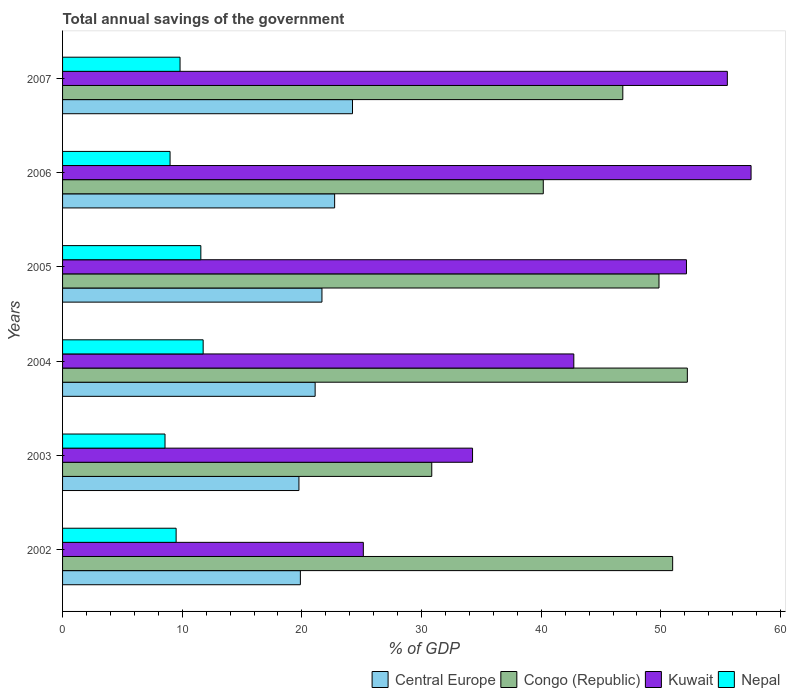How many different coloured bars are there?
Offer a terse response. 4. Are the number of bars per tick equal to the number of legend labels?
Your answer should be very brief. Yes. How many bars are there on the 4th tick from the top?
Keep it short and to the point. 4. How many bars are there on the 6th tick from the bottom?
Your response must be concise. 4. What is the total annual savings of the government in Kuwait in 2007?
Keep it short and to the point. 55.55. Across all years, what is the maximum total annual savings of the government in Nepal?
Your response must be concise. 11.75. Across all years, what is the minimum total annual savings of the government in Congo (Republic)?
Your response must be concise. 30.85. In which year was the total annual savings of the government in Nepal maximum?
Offer a very short reply. 2004. What is the total total annual savings of the government in Nepal in the graph?
Ensure brevity in your answer.  60.16. What is the difference between the total annual savings of the government in Nepal in 2003 and that in 2004?
Your response must be concise. -3.19. What is the difference between the total annual savings of the government in Congo (Republic) in 2004 and the total annual savings of the government in Kuwait in 2003?
Your response must be concise. 17.95. What is the average total annual savings of the government in Nepal per year?
Your answer should be very brief. 10.03. In the year 2005, what is the difference between the total annual savings of the government in Nepal and total annual savings of the government in Kuwait?
Your answer should be very brief. -40.58. In how many years, is the total annual savings of the government in Congo (Republic) greater than 18 %?
Ensure brevity in your answer.  6. What is the ratio of the total annual savings of the government in Central Europe in 2005 to that in 2007?
Your answer should be very brief. 0.89. Is the total annual savings of the government in Congo (Republic) in 2002 less than that in 2003?
Provide a succinct answer. No. What is the difference between the highest and the second highest total annual savings of the government in Nepal?
Your answer should be very brief. 0.19. What is the difference between the highest and the lowest total annual savings of the government in Kuwait?
Offer a very short reply. 32.4. Is it the case that in every year, the sum of the total annual savings of the government in Kuwait and total annual savings of the government in Congo (Republic) is greater than the sum of total annual savings of the government in Nepal and total annual savings of the government in Central Europe?
Offer a terse response. No. What does the 2nd bar from the top in 2004 represents?
Keep it short and to the point. Kuwait. What does the 4th bar from the bottom in 2006 represents?
Your response must be concise. Nepal. Is it the case that in every year, the sum of the total annual savings of the government in Congo (Republic) and total annual savings of the government in Kuwait is greater than the total annual savings of the government in Nepal?
Make the answer very short. Yes. Are all the bars in the graph horizontal?
Provide a succinct answer. Yes. What is the difference between two consecutive major ticks on the X-axis?
Keep it short and to the point. 10. Are the values on the major ticks of X-axis written in scientific E-notation?
Offer a very short reply. No. Where does the legend appear in the graph?
Keep it short and to the point. Bottom right. What is the title of the graph?
Provide a succinct answer. Total annual savings of the government. What is the label or title of the X-axis?
Your answer should be very brief. % of GDP. What is the label or title of the Y-axis?
Your response must be concise. Years. What is the % of GDP in Central Europe in 2002?
Your answer should be very brief. 19.87. What is the % of GDP of Congo (Republic) in 2002?
Offer a terse response. 50.98. What is the % of GDP of Kuwait in 2002?
Offer a terse response. 25.13. What is the % of GDP of Nepal in 2002?
Ensure brevity in your answer.  9.49. What is the % of GDP of Central Europe in 2003?
Your response must be concise. 19.75. What is the % of GDP of Congo (Republic) in 2003?
Your response must be concise. 30.85. What is the % of GDP of Kuwait in 2003?
Your answer should be compact. 34.26. What is the % of GDP of Nepal in 2003?
Your answer should be compact. 8.56. What is the % of GDP of Central Europe in 2004?
Make the answer very short. 21.11. What is the % of GDP of Congo (Republic) in 2004?
Provide a succinct answer. 52.21. What is the % of GDP in Kuwait in 2004?
Give a very brief answer. 42.72. What is the % of GDP in Nepal in 2004?
Your answer should be very brief. 11.75. What is the % of GDP of Central Europe in 2005?
Make the answer very short. 21.68. What is the % of GDP of Congo (Republic) in 2005?
Provide a short and direct response. 49.84. What is the % of GDP of Kuwait in 2005?
Your answer should be very brief. 52.14. What is the % of GDP in Nepal in 2005?
Keep it short and to the point. 11.56. What is the % of GDP of Central Europe in 2006?
Provide a succinct answer. 22.74. What is the % of GDP in Congo (Republic) in 2006?
Your answer should be compact. 40.17. What is the % of GDP of Kuwait in 2006?
Provide a succinct answer. 57.54. What is the % of GDP in Nepal in 2006?
Make the answer very short. 8.98. What is the % of GDP of Central Europe in 2007?
Provide a succinct answer. 24.23. What is the % of GDP of Congo (Republic) in 2007?
Offer a terse response. 46.82. What is the % of GDP in Kuwait in 2007?
Your response must be concise. 55.55. What is the % of GDP of Nepal in 2007?
Give a very brief answer. 9.82. Across all years, what is the maximum % of GDP of Central Europe?
Give a very brief answer. 24.23. Across all years, what is the maximum % of GDP of Congo (Republic)?
Your answer should be compact. 52.21. Across all years, what is the maximum % of GDP in Kuwait?
Give a very brief answer. 57.54. Across all years, what is the maximum % of GDP in Nepal?
Keep it short and to the point. 11.75. Across all years, what is the minimum % of GDP in Central Europe?
Provide a succinct answer. 19.75. Across all years, what is the minimum % of GDP in Congo (Republic)?
Provide a succinct answer. 30.85. Across all years, what is the minimum % of GDP in Kuwait?
Offer a very short reply. 25.13. Across all years, what is the minimum % of GDP of Nepal?
Your response must be concise. 8.56. What is the total % of GDP of Central Europe in the graph?
Keep it short and to the point. 129.38. What is the total % of GDP in Congo (Republic) in the graph?
Offer a very short reply. 270.88. What is the total % of GDP in Kuwait in the graph?
Your response must be concise. 267.35. What is the total % of GDP in Nepal in the graph?
Your answer should be compact. 60.16. What is the difference between the % of GDP of Central Europe in 2002 and that in 2003?
Offer a very short reply. 0.12. What is the difference between the % of GDP in Congo (Republic) in 2002 and that in 2003?
Your response must be concise. 20.13. What is the difference between the % of GDP in Kuwait in 2002 and that in 2003?
Your answer should be very brief. -9.13. What is the difference between the % of GDP of Nepal in 2002 and that in 2003?
Your response must be concise. 0.93. What is the difference between the % of GDP in Central Europe in 2002 and that in 2004?
Ensure brevity in your answer.  -1.23. What is the difference between the % of GDP of Congo (Republic) in 2002 and that in 2004?
Your answer should be compact. -1.23. What is the difference between the % of GDP of Kuwait in 2002 and that in 2004?
Offer a terse response. -17.59. What is the difference between the % of GDP of Nepal in 2002 and that in 2004?
Offer a terse response. -2.26. What is the difference between the % of GDP of Central Europe in 2002 and that in 2005?
Offer a very short reply. -1.8. What is the difference between the % of GDP in Congo (Republic) in 2002 and that in 2005?
Offer a very short reply. 1.14. What is the difference between the % of GDP of Kuwait in 2002 and that in 2005?
Keep it short and to the point. -27. What is the difference between the % of GDP of Nepal in 2002 and that in 2005?
Your answer should be very brief. -2.07. What is the difference between the % of GDP in Central Europe in 2002 and that in 2006?
Provide a succinct answer. -2.86. What is the difference between the % of GDP in Congo (Republic) in 2002 and that in 2006?
Give a very brief answer. 10.81. What is the difference between the % of GDP in Kuwait in 2002 and that in 2006?
Give a very brief answer. -32.4. What is the difference between the % of GDP in Nepal in 2002 and that in 2006?
Your answer should be compact. 0.51. What is the difference between the % of GDP of Central Europe in 2002 and that in 2007?
Keep it short and to the point. -4.36. What is the difference between the % of GDP in Congo (Republic) in 2002 and that in 2007?
Keep it short and to the point. 4.17. What is the difference between the % of GDP of Kuwait in 2002 and that in 2007?
Offer a very short reply. -30.42. What is the difference between the % of GDP of Nepal in 2002 and that in 2007?
Ensure brevity in your answer.  -0.33. What is the difference between the % of GDP of Central Europe in 2003 and that in 2004?
Give a very brief answer. -1.35. What is the difference between the % of GDP of Congo (Republic) in 2003 and that in 2004?
Offer a terse response. -21.36. What is the difference between the % of GDP of Kuwait in 2003 and that in 2004?
Ensure brevity in your answer.  -8.46. What is the difference between the % of GDP in Nepal in 2003 and that in 2004?
Provide a short and direct response. -3.19. What is the difference between the % of GDP in Central Europe in 2003 and that in 2005?
Offer a terse response. -1.92. What is the difference between the % of GDP of Congo (Republic) in 2003 and that in 2005?
Give a very brief answer. -18.99. What is the difference between the % of GDP of Kuwait in 2003 and that in 2005?
Your answer should be very brief. -17.88. What is the difference between the % of GDP in Nepal in 2003 and that in 2005?
Your answer should be very brief. -2.99. What is the difference between the % of GDP of Central Europe in 2003 and that in 2006?
Your answer should be very brief. -2.98. What is the difference between the % of GDP in Congo (Republic) in 2003 and that in 2006?
Offer a terse response. -9.32. What is the difference between the % of GDP of Kuwait in 2003 and that in 2006?
Your answer should be very brief. -23.28. What is the difference between the % of GDP in Nepal in 2003 and that in 2006?
Your response must be concise. -0.42. What is the difference between the % of GDP of Central Europe in 2003 and that in 2007?
Make the answer very short. -4.48. What is the difference between the % of GDP in Congo (Republic) in 2003 and that in 2007?
Offer a very short reply. -15.97. What is the difference between the % of GDP in Kuwait in 2003 and that in 2007?
Provide a succinct answer. -21.29. What is the difference between the % of GDP in Nepal in 2003 and that in 2007?
Your answer should be very brief. -1.26. What is the difference between the % of GDP of Central Europe in 2004 and that in 2005?
Ensure brevity in your answer.  -0.57. What is the difference between the % of GDP of Congo (Republic) in 2004 and that in 2005?
Keep it short and to the point. 2.37. What is the difference between the % of GDP of Kuwait in 2004 and that in 2005?
Provide a succinct answer. -9.41. What is the difference between the % of GDP in Nepal in 2004 and that in 2005?
Your answer should be very brief. 0.19. What is the difference between the % of GDP of Central Europe in 2004 and that in 2006?
Give a very brief answer. -1.63. What is the difference between the % of GDP in Congo (Republic) in 2004 and that in 2006?
Provide a succinct answer. 12.04. What is the difference between the % of GDP of Kuwait in 2004 and that in 2006?
Provide a succinct answer. -14.81. What is the difference between the % of GDP of Nepal in 2004 and that in 2006?
Your response must be concise. 2.77. What is the difference between the % of GDP of Central Europe in 2004 and that in 2007?
Provide a short and direct response. -3.12. What is the difference between the % of GDP of Congo (Republic) in 2004 and that in 2007?
Your response must be concise. 5.39. What is the difference between the % of GDP in Kuwait in 2004 and that in 2007?
Your response must be concise. -12.83. What is the difference between the % of GDP of Nepal in 2004 and that in 2007?
Make the answer very short. 1.93. What is the difference between the % of GDP of Central Europe in 2005 and that in 2006?
Make the answer very short. -1.06. What is the difference between the % of GDP in Congo (Republic) in 2005 and that in 2006?
Ensure brevity in your answer.  9.67. What is the difference between the % of GDP in Kuwait in 2005 and that in 2006?
Make the answer very short. -5.4. What is the difference between the % of GDP in Nepal in 2005 and that in 2006?
Give a very brief answer. 2.57. What is the difference between the % of GDP of Central Europe in 2005 and that in 2007?
Your answer should be very brief. -2.55. What is the difference between the % of GDP in Congo (Republic) in 2005 and that in 2007?
Give a very brief answer. 3.02. What is the difference between the % of GDP of Kuwait in 2005 and that in 2007?
Give a very brief answer. -3.42. What is the difference between the % of GDP of Nepal in 2005 and that in 2007?
Offer a very short reply. 1.74. What is the difference between the % of GDP in Central Europe in 2006 and that in 2007?
Keep it short and to the point. -1.49. What is the difference between the % of GDP in Congo (Republic) in 2006 and that in 2007?
Ensure brevity in your answer.  -6.65. What is the difference between the % of GDP of Kuwait in 2006 and that in 2007?
Provide a short and direct response. 1.98. What is the difference between the % of GDP of Nepal in 2006 and that in 2007?
Your answer should be compact. -0.83. What is the difference between the % of GDP of Central Europe in 2002 and the % of GDP of Congo (Republic) in 2003?
Offer a very short reply. -10.98. What is the difference between the % of GDP in Central Europe in 2002 and the % of GDP in Kuwait in 2003?
Offer a terse response. -14.39. What is the difference between the % of GDP in Central Europe in 2002 and the % of GDP in Nepal in 2003?
Offer a terse response. 11.31. What is the difference between the % of GDP of Congo (Republic) in 2002 and the % of GDP of Kuwait in 2003?
Provide a succinct answer. 16.72. What is the difference between the % of GDP in Congo (Republic) in 2002 and the % of GDP in Nepal in 2003?
Keep it short and to the point. 42.42. What is the difference between the % of GDP in Kuwait in 2002 and the % of GDP in Nepal in 2003?
Offer a terse response. 16.57. What is the difference between the % of GDP in Central Europe in 2002 and the % of GDP in Congo (Republic) in 2004?
Make the answer very short. -32.34. What is the difference between the % of GDP of Central Europe in 2002 and the % of GDP of Kuwait in 2004?
Your answer should be very brief. -22.85. What is the difference between the % of GDP in Central Europe in 2002 and the % of GDP in Nepal in 2004?
Provide a succinct answer. 8.12. What is the difference between the % of GDP of Congo (Republic) in 2002 and the % of GDP of Kuwait in 2004?
Your answer should be very brief. 8.26. What is the difference between the % of GDP of Congo (Republic) in 2002 and the % of GDP of Nepal in 2004?
Offer a terse response. 39.24. What is the difference between the % of GDP of Kuwait in 2002 and the % of GDP of Nepal in 2004?
Ensure brevity in your answer.  13.38. What is the difference between the % of GDP in Central Europe in 2002 and the % of GDP in Congo (Republic) in 2005?
Ensure brevity in your answer.  -29.97. What is the difference between the % of GDP in Central Europe in 2002 and the % of GDP in Kuwait in 2005?
Your response must be concise. -32.26. What is the difference between the % of GDP in Central Europe in 2002 and the % of GDP in Nepal in 2005?
Provide a short and direct response. 8.32. What is the difference between the % of GDP in Congo (Republic) in 2002 and the % of GDP in Kuwait in 2005?
Your answer should be very brief. -1.15. What is the difference between the % of GDP of Congo (Republic) in 2002 and the % of GDP of Nepal in 2005?
Ensure brevity in your answer.  39.43. What is the difference between the % of GDP in Kuwait in 2002 and the % of GDP in Nepal in 2005?
Make the answer very short. 13.58. What is the difference between the % of GDP of Central Europe in 2002 and the % of GDP of Congo (Republic) in 2006?
Give a very brief answer. -20.3. What is the difference between the % of GDP of Central Europe in 2002 and the % of GDP of Kuwait in 2006?
Keep it short and to the point. -37.66. What is the difference between the % of GDP in Central Europe in 2002 and the % of GDP in Nepal in 2006?
Your answer should be very brief. 10.89. What is the difference between the % of GDP in Congo (Republic) in 2002 and the % of GDP in Kuwait in 2006?
Provide a short and direct response. -6.55. What is the difference between the % of GDP of Congo (Republic) in 2002 and the % of GDP of Nepal in 2006?
Offer a terse response. 42. What is the difference between the % of GDP in Kuwait in 2002 and the % of GDP in Nepal in 2006?
Make the answer very short. 16.15. What is the difference between the % of GDP of Central Europe in 2002 and the % of GDP of Congo (Republic) in 2007?
Provide a succinct answer. -26.95. What is the difference between the % of GDP in Central Europe in 2002 and the % of GDP in Kuwait in 2007?
Your response must be concise. -35.68. What is the difference between the % of GDP in Central Europe in 2002 and the % of GDP in Nepal in 2007?
Give a very brief answer. 10.06. What is the difference between the % of GDP of Congo (Republic) in 2002 and the % of GDP of Kuwait in 2007?
Offer a very short reply. -4.57. What is the difference between the % of GDP in Congo (Republic) in 2002 and the % of GDP in Nepal in 2007?
Keep it short and to the point. 41.17. What is the difference between the % of GDP in Kuwait in 2002 and the % of GDP in Nepal in 2007?
Your answer should be compact. 15.32. What is the difference between the % of GDP of Central Europe in 2003 and the % of GDP of Congo (Republic) in 2004?
Give a very brief answer. -32.46. What is the difference between the % of GDP of Central Europe in 2003 and the % of GDP of Kuwait in 2004?
Give a very brief answer. -22.97. What is the difference between the % of GDP in Central Europe in 2003 and the % of GDP in Nepal in 2004?
Keep it short and to the point. 8. What is the difference between the % of GDP of Congo (Republic) in 2003 and the % of GDP of Kuwait in 2004?
Keep it short and to the point. -11.87. What is the difference between the % of GDP in Congo (Republic) in 2003 and the % of GDP in Nepal in 2004?
Your answer should be compact. 19.1. What is the difference between the % of GDP of Kuwait in 2003 and the % of GDP of Nepal in 2004?
Ensure brevity in your answer.  22.51. What is the difference between the % of GDP in Central Europe in 2003 and the % of GDP in Congo (Republic) in 2005?
Provide a succinct answer. -30.09. What is the difference between the % of GDP in Central Europe in 2003 and the % of GDP in Kuwait in 2005?
Your answer should be very brief. -32.39. What is the difference between the % of GDP in Central Europe in 2003 and the % of GDP in Nepal in 2005?
Offer a terse response. 8.2. What is the difference between the % of GDP in Congo (Republic) in 2003 and the % of GDP in Kuwait in 2005?
Offer a terse response. -21.29. What is the difference between the % of GDP in Congo (Republic) in 2003 and the % of GDP in Nepal in 2005?
Ensure brevity in your answer.  19.3. What is the difference between the % of GDP of Kuwait in 2003 and the % of GDP of Nepal in 2005?
Your answer should be compact. 22.71. What is the difference between the % of GDP of Central Europe in 2003 and the % of GDP of Congo (Republic) in 2006?
Offer a terse response. -20.42. What is the difference between the % of GDP in Central Europe in 2003 and the % of GDP in Kuwait in 2006?
Ensure brevity in your answer.  -37.78. What is the difference between the % of GDP in Central Europe in 2003 and the % of GDP in Nepal in 2006?
Your answer should be very brief. 10.77. What is the difference between the % of GDP in Congo (Republic) in 2003 and the % of GDP in Kuwait in 2006?
Your answer should be very brief. -26.68. What is the difference between the % of GDP of Congo (Republic) in 2003 and the % of GDP of Nepal in 2006?
Your answer should be very brief. 21.87. What is the difference between the % of GDP of Kuwait in 2003 and the % of GDP of Nepal in 2006?
Keep it short and to the point. 25.28. What is the difference between the % of GDP in Central Europe in 2003 and the % of GDP in Congo (Republic) in 2007?
Offer a terse response. -27.07. What is the difference between the % of GDP of Central Europe in 2003 and the % of GDP of Kuwait in 2007?
Your answer should be compact. -35.8. What is the difference between the % of GDP of Central Europe in 2003 and the % of GDP of Nepal in 2007?
Make the answer very short. 9.94. What is the difference between the % of GDP of Congo (Republic) in 2003 and the % of GDP of Kuwait in 2007?
Offer a terse response. -24.7. What is the difference between the % of GDP of Congo (Republic) in 2003 and the % of GDP of Nepal in 2007?
Ensure brevity in your answer.  21.04. What is the difference between the % of GDP in Kuwait in 2003 and the % of GDP in Nepal in 2007?
Your answer should be compact. 24.44. What is the difference between the % of GDP of Central Europe in 2004 and the % of GDP of Congo (Republic) in 2005?
Your answer should be compact. -28.74. What is the difference between the % of GDP in Central Europe in 2004 and the % of GDP in Kuwait in 2005?
Offer a terse response. -31.03. What is the difference between the % of GDP of Central Europe in 2004 and the % of GDP of Nepal in 2005?
Give a very brief answer. 9.55. What is the difference between the % of GDP of Congo (Republic) in 2004 and the % of GDP of Kuwait in 2005?
Your answer should be compact. 0.07. What is the difference between the % of GDP in Congo (Republic) in 2004 and the % of GDP in Nepal in 2005?
Give a very brief answer. 40.66. What is the difference between the % of GDP of Kuwait in 2004 and the % of GDP of Nepal in 2005?
Offer a very short reply. 31.17. What is the difference between the % of GDP of Central Europe in 2004 and the % of GDP of Congo (Republic) in 2006?
Give a very brief answer. -19.07. What is the difference between the % of GDP of Central Europe in 2004 and the % of GDP of Kuwait in 2006?
Provide a succinct answer. -36.43. What is the difference between the % of GDP of Central Europe in 2004 and the % of GDP of Nepal in 2006?
Provide a short and direct response. 12.12. What is the difference between the % of GDP of Congo (Republic) in 2004 and the % of GDP of Kuwait in 2006?
Offer a terse response. -5.32. What is the difference between the % of GDP in Congo (Republic) in 2004 and the % of GDP in Nepal in 2006?
Your answer should be very brief. 43.23. What is the difference between the % of GDP of Kuwait in 2004 and the % of GDP of Nepal in 2006?
Your answer should be compact. 33.74. What is the difference between the % of GDP in Central Europe in 2004 and the % of GDP in Congo (Republic) in 2007?
Keep it short and to the point. -25.71. What is the difference between the % of GDP of Central Europe in 2004 and the % of GDP of Kuwait in 2007?
Offer a terse response. -34.45. What is the difference between the % of GDP in Central Europe in 2004 and the % of GDP in Nepal in 2007?
Make the answer very short. 11.29. What is the difference between the % of GDP of Congo (Republic) in 2004 and the % of GDP of Kuwait in 2007?
Give a very brief answer. -3.34. What is the difference between the % of GDP of Congo (Republic) in 2004 and the % of GDP of Nepal in 2007?
Your response must be concise. 42.39. What is the difference between the % of GDP in Kuwait in 2004 and the % of GDP in Nepal in 2007?
Offer a very short reply. 32.91. What is the difference between the % of GDP in Central Europe in 2005 and the % of GDP in Congo (Republic) in 2006?
Offer a very short reply. -18.5. What is the difference between the % of GDP of Central Europe in 2005 and the % of GDP of Kuwait in 2006?
Ensure brevity in your answer.  -35.86. What is the difference between the % of GDP in Central Europe in 2005 and the % of GDP in Nepal in 2006?
Ensure brevity in your answer.  12.69. What is the difference between the % of GDP of Congo (Republic) in 2005 and the % of GDP of Kuwait in 2006?
Provide a succinct answer. -7.69. What is the difference between the % of GDP in Congo (Republic) in 2005 and the % of GDP in Nepal in 2006?
Keep it short and to the point. 40.86. What is the difference between the % of GDP in Kuwait in 2005 and the % of GDP in Nepal in 2006?
Provide a short and direct response. 43.16. What is the difference between the % of GDP of Central Europe in 2005 and the % of GDP of Congo (Republic) in 2007?
Provide a short and direct response. -25.14. What is the difference between the % of GDP in Central Europe in 2005 and the % of GDP in Kuwait in 2007?
Your answer should be very brief. -33.88. What is the difference between the % of GDP in Central Europe in 2005 and the % of GDP in Nepal in 2007?
Ensure brevity in your answer.  11.86. What is the difference between the % of GDP of Congo (Republic) in 2005 and the % of GDP of Kuwait in 2007?
Provide a succinct answer. -5.71. What is the difference between the % of GDP of Congo (Republic) in 2005 and the % of GDP of Nepal in 2007?
Your answer should be very brief. 40.03. What is the difference between the % of GDP in Kuwait in 2005 and the % of GDP in Nepal in 2007?
Give a very brief answer. 42.32. What is the difference between the % of GDP of Central Europe in 2006 and the % of GDP of Congo (Republic) in 2007?
Make the answer very short. -24.08. What is the difference between the % of GDP of Central Europe in 2006 and the % of GDP of Kuwait in 2007?
Make the answer very short. -32.82. What is the difference between the % of GDP of Central Europe in 2006 and the % of GDP of Nepal in 2007?
Make the answer very short. 12.92. What is the difference between the % of GDP in Congo (Republic) in 2006 and the % of GDP in Kuwait in 2007?
Your answer should be compact. -15.38. What is the difference between the % of GDP of Congo (Republic) in 2006 and the % of GDP of Nepal in 2007?
Your answer should be compact. 30.35. What is the difference between the % of GDP in Kuwait in 2006 and the % of GDP in Nepal in 2007?
Your answer should be very brief. 47.72. What is the average % of GDP in Central Europe per year?
Provide a short and direct response. 21.56. What is the average % of GDP in Congo (Republic) per year?
Keep it short and to the point. 45.15. What is the average % of GDP in Kuwait per year?
Give a very brief answer. 44.56. What is the average % of GDP of Nepal per year?
Offer a terse response. 10.03. In the year 2002, what is the difference between the % of GDP in Central Europe and % of GDP in Congo (Republic)?
Keep it short and to the point. -31.11. In the year 2002, what is the difference between the % of GDP in Central Europe and % of GDP in Kuwait?
Your answer should be compact. -5.26. In the year 2002, what is the difference between the % of GDP of Central Europe and % of GDP of Nepal?
Your answer should be very brief. 10.38. In the year 2002, what is the difference between the % of GDP in Congo (Republic) and % of GDP in Kuwait?
Offer a terse response. 25.85. In the year 2002, what is the difference between the % of GDP of Congo (Republic) and % of GDP of Nepal?
Make the answer very short. 41.49. In the year 2002, what is the difference between the % of GDP of Kuwait and % of GDP of Nepal?
Keep it short and to the point. 15.64. In the year 2003, what is the difference between the % of GDP in Central Europe and % of GDP in Congo (Republic)?
Your answer should be very brief. -11.1. In the year 2003, what is the difference between the % of GDP of Central Europe and % of GDP of Kuwait?
Your answer should be compact. -14.51. In the year 2003, what is the difference between the % of GDP in Central Europe and % of GDP in Nepal?
Your answer should be compact. 11.19. In the year 2003, what is the difference between the % of GDP of Congo (Republic) and % of GDP of Kuwait?
Your answer should be very brief. -3.41. In the year 2003, what is the difference between the % of GDP in Congo (Republic) and % of GDP in Nepal?
Give a very brief answer. 22.29. In the year 2003, what is the difference between the % of GDP of Kuwait and % of GDP of Nepal?
Provide a succinct answer. 25.7. In the year 2004, what is the difference between the % of GDP of Central Europe and % of GDP of Congo (Republic)?
Keep it short and to the point. -31.11. In the year 2004, what is the difference between the % of GDP in Central Europe and % of GDP in Kuwait?
Offer a terse response. -21.62. In the year 2004, what is the difference between the % of GDP of Central Europe and % of GDP of Nepal?
Offer a very short reply. 9.36. In the year 2004, what is the difference between the % of GDP of Congo (Republic) and % of GDP of Kuwait?
Make the answer very short. 9.49. In the year 2004, what is the difference between the % of GDP of Congo (Republic) and % of GDP of Nepal?
Make the answer very short. 40.46. In the year 2004, what is the difference between the % of GDP in Kuwait and % of GDP in Nepal?
Offer a terse response. 30.98. In the year 2005, what is the difference between the % of GDP in Central Europe and % of GDP in Congo (Republic)?
Offer a very short reply. -28.17. In the year 2005, what is the difference between the % of GDP of Central Europe and % of GDP of Kuwait?
Your response must be concise. -30.46. In the year 2005, what is the difference between the % of GDP in Central Europe and % of GDP in Nepal?
Provide a short and direct response. 10.12. In the year 2005, what is the difference between the % of GDP of Congo (Republic) and % of GDP of Kuwait?
Ensure brevity in your answer.  -2.3. In the year 2005, what is the difference between the % of GDP in Congo (Republic) and % of GDP in Nepal?
Offer a very short reply. 38.29. In the year 2005, what is the difference between the % of GDP of Kuwait and % of GDP of Nepal?
Your answer should be very brief. 40.58. In the year 2006, what is the difference between the % of GDP in Central Europe and % of GDP in Congo (Republic)?
Give a very brief answer. -17.44. In the year 2006, what is the difference between the % of GDP in Central Europe and % of GDP in Kuwait?
Give a very brief answer. -34.8. In the year 2006, what is the difference between the % of GDP of Central Europe and % of GDP of Nepal?
Keep it short and to the point. 13.75. In the year 2006, what is the difference between the % of GDP in Congo (Republic) and % of GDP in Kuwait?
Offer a very short reply. -17.36. In the year 2006, what is the difference between the % of GDP of Congo (Republic) and % of GDP of Nepal?
Make the answer very short. 31.19. In the year 2006, what is the difference between the % of GDP of Kuwait and % of GDP of Nepal?
Make the answer very short. 48.55. In the year 2007, what is the difference between the % of GDP in Central Europe and % of GDP in Congo (Republic)?
Your answer should be very brief. -22.59. In the year 2007, what is the difference between the % of GDP in Central Europe and % of GDP in Kuwait?
Keep it short and to the point. -31.33. In the year 2007, what is the difference between the % of GDP in Central Europe and % of GDP in Nepal?
Offer a very short reply. 14.41. In the year 2007, what is the difference between the % of GDP in Congo (Republic) and % of GDP in Kuwait?
Your response must be concise. -8.73. In the year 2007, what is the difference between the % of GDP in Congo (Republic) and % of GDP in Nepal?
Offer a terse response. 37. In the year 2007, what is the difference between the % of GDP in Kuwait and % of GDP in Nepal?
Offer a terse response. 45.74. What is the ratio of the % of GDP of Central Europe in 2002 to that in 2003?
Keep it short and to the point. 1.01. What is the ratio of the % of GDP of Congo (Republic) in 2002 to that in 2003?
Offer a terse response. 1.65. What is the ratio of the % of GDP in Kuwait in 2002 to that in 2003?
Make the answer very short. 0.73. What is the ratio of the % of GDP in Nepal in 2002 to that in 2003?
Make the answer very short. 1.11. What is the ratio of the % of GDP of Central Europe in 2002 to that in 2004?
Give a very brief answer. 0.94. What is the ratio of the % of GDP of Congo (Republic) in 2002 to that in 2004?
Your answer should be compact. 0.98. What is the ratio of the % of GDP in Kuwait in 2002 to that in 2004?
Provide a short and direct response. 0.59. What is the ratio of the % of GDP in Nepal in 2002 to that in 2004?
Offer a terse response. 0.81. What is the ratio of the % of GDP of Central Europe in 2002 to that in 2005?
Offer a very short reply. 0.92. What is the ratio of the % of GDP in Congo (Republic) in 2002 to that in 2005?
Keep it short and to the point. 1.02. What is the ratio of the % of GDP in Kuwait in 2002 to that in 2005?
Provide a short and direct response. 0.48. What is the ratio of the % of GDP of Nepal in 2002 to that in 2005?
Provide a succinct answer. 0.82. What is the ratio of the % of GDP in Central Europe in 2002 to that in 2006?
Ensure brevity in your answer.  0.87. What is the ratio of the % of GDP of Congo (Republic) in 2002 to that in 2006?
Keep it short and to the point. 1.27. What is the ratio of the % of GDP in Kuwait in 2002 to that in 2006?
Make the answer very short. 0.44. What is the ratio of the % of GDP of Nepal in 2002 to that in 2006?
Provide a succinct answer. 1.06. What is the ratio of the % of GDP in Central Europe in 2002 to that in 2007?
Provide a short and direct response. 0.82. What is the ratio of the % of GDP in Congo (Republic) in 2002 to that in 2007?
Your response must be concise. 1.09. What is the ratio of the % of GDP of Kuwait in 2002 to that in 2007?
Offer a terse response. 0.45. What is the ratio of the % of GDP of Nepal in 2002 to that in 2007?
Your answer should be very brief. 0.97. What is the ratio of the % of GDP of Central Europe in 2003 to that in 2004?
Your answer should be very brief. 0.94. What is the ratio of the % of GDP in Congo (Republic) in 2003 to that in 2004?
Give a very brief answer. 0.59. What is the ratio of the % of GDP in Kuwait in 2003 to that in 2004?
Ensure brevity in your answer.  0.8. What is the ratio of the % of GDP of Nepal in 2003 to that in 2004?
Provide a short and direct response. 0.73. What is the ratio of the % of GDP in Central Europe in 2003 to that in 2005?
Offer a very short reply. 0.91. What is the ratio of the % of GDP of Congo (Republic) in 2003 to that in 2005?
Your response must be concise. 0.62. What is the ratio of the % of GDP of Kuwait in 2003 to that in 2005?
Offer a terse response. 0.66. What is the ratio of the % of GDP in Nepal in 2003 to that in 2005?
Offer a terse response. 0.74. What is the ratio of the % of GDP in Central Europe in 2003 to that in 2006?
Your answer should be compact. 0.87. What is the ratio of the % of GDP in Congo (Republic) in 2003 to that in 2006?
Ensure brevity in your answer.  0.77. What is the ratio of the % of GDP of Kuwait in 2003 to that in 2006?
Offer a very short reply. 0.6. What is the ratio of the % of GDP of Nepal in 2003 to that in 2006?
Keep it short and to the point. 0.95. What is the ratio of the % of GDP of Central Europe in 2003 to that in 2007?
Offer a terse response. 0.82. What is the ratio of the % of GDP of Congo (Republic) in 2003 to that in 2007?
Your answer should be very brief. 0.66. What is the ratio of the % of GDP of Kuwait in 2003 to that in 2007?
Provide a succinct answer. 0.62. What is the ratio of the % of GDP of Nepal in 2003 to that in 2007?
Give a very brief answer. 0.87. What is the ratio of the % of GDP in Central Europe in 2004 to that in 2005?
Provide a succinct answer. 0.97. What is the ratio of the % of GDP in Congo (Republic) in 2004 to that in 2005?
Keep it short and to the point. 1.05. What is the ratio of the % of GDP of Kuwait in 2004 to that in 2005?
Your answer should be very brief. 0.82. What is the ratio of the % of GDP in Nepal in 2004 to that in 2005?
Make the answer very short. 1.02. What is the ratio of the % of GDP in Central Europe in 2004 to that in 2006?
Make the answer very short. 0.93. What is the ratio of the % of GDP of Congo (Republic) in 2004 to that in 2006?
Ensure brevity in your answer.  1.3. What is the ratio of the % of GDP in Kuwait in 2004 to that in 2006?
Offer a very short reply. 0.74. What is the ratio of the % of GDP of Nepal in 2004 to that in 2006?
Your answer should be compact. 1.31. What is the ratio of the % of GDP of Central Europe in 2004 to that in 2007?
Provide a short and direct response. 0.87. What is the ratio of the % of GDP in Congo (Republic) in 2004 to that in 2007?
Provide a short and direct response. 1.12. What is the ratio of the % of GDP in Kuwait in 2004 to that in 2007?
Your answer should be very brief. 0.77. What is the ratio of the % of GDP in Nepal in 2004 to that in 2007?
Offer a very short reply. 1.2. What is the ratio of the % of GDP of Central Europe in 2005 to that in 2006?
Make the answer very short. 0.95. What is the ratio of the % of GDP of Congo (Republic) in 2005 to that in 2006?
Give a very brief answer. 1.24. What is the ratio of the % of GDP of Kuwait in 2005 to that in 2006?
Ensure brevity in your answer.  0.91. What is the ratio of the % of GDP in Nepal in 2005 to that in 2006?
Your answer should be very brief. 1.29. What is the ratio of the % of GDP of Central Europe in 2005 to that in 2007?
Make the answer very short. 0.89. What is the ratio of the % of GDP of Congo (Republic) in 2005 to that in 2007?
Ensure brevity in your answer.  1.06. What is the ratio of the % of GDP in Kuwait in 2005 to that in 2007?
Provide a short and direct response. 0.94. What is the ratio of the % of GDP of Nepal in 2005 to that in 2007?
Make the answer very short. 1.18. What is the ratio of the % of GDP of Central Europe in 2006 to that in 2007?
Provide a short and direct response. 0.94. What is the ratio of the % of GDP of Congo (Republic) in 2006 to that in 2007?
Make the answer very short. 0.86. What is the ratio of the % of GDP in Kuwait in 2006 to that in 2007?
Provide a short and direct response. 1.04. What is the ratio of the % of GDP of Nepal in 2006 to that in 2007?
Give a very brief answer. 0.92. What is the difference between the highest and the second highest % of GDP in Central Europe?
Provide a short and direct response. 1.49. What is the difference between the highest and the second highest % of GDP of Congo (Republic)?
Make the answer very short. 1.23. What is the difference between the highest and the second highest % of GDP in Kuwait?
Your answer should be compact. 1.98. What is the difference between the highest and the second highest % of GDP of Nepal?
Provide a short and direct response. 0.19. What is the difference between the highest and the lowest % of GDP of Central Europe?
Ensure brevity in your answer.  4.48. What is the difference between the highest and the lowest % of GDP in Congo (Republic)?
Offer a very short reply. 21.36. What is the difference between the highest and the lowest % of GDP of Kuwait?
Keep it short and to the point. 32.4. What is the difference between the highest and the lowest % of GDP in Nepal?
Provide a short and direct response. 3.19. 